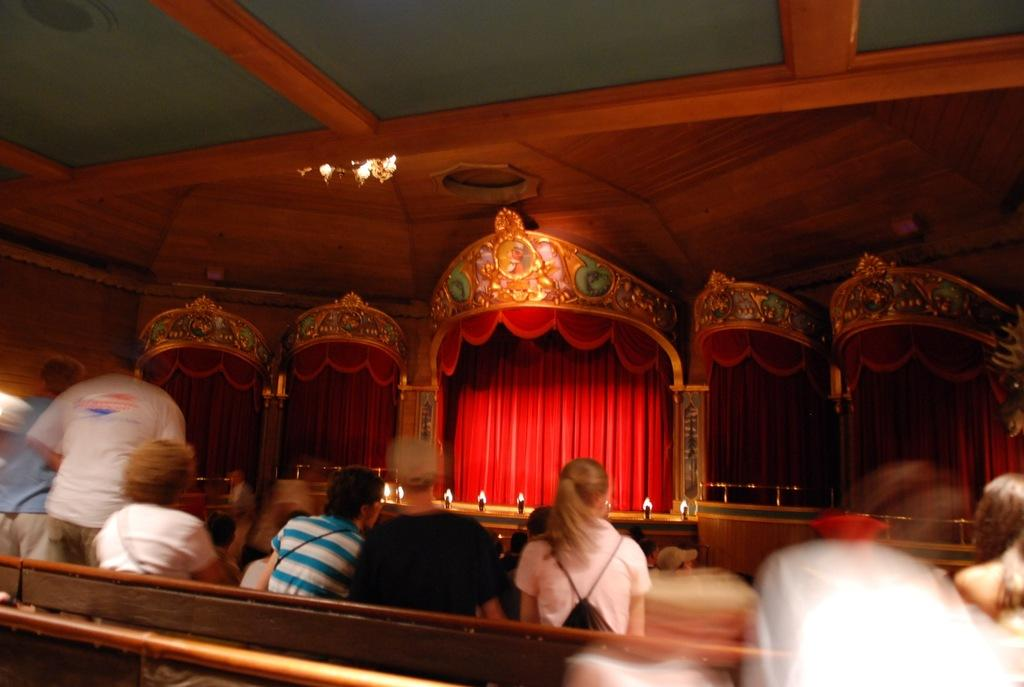What are the people in the image doing? There are people sitting and standing in the image. What can be seen illuminating the scene in the image? There are lights visible in the image. What type of covering is present in the image? There is a curtain in the image. What type of location does the image appear to depict? The setting appears to be an auditorium. What type of wood can be seen floating in the air in the image? There is no wood present in the image, let alone floating in the air. 